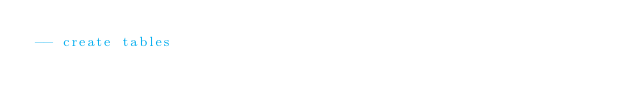<code> <loc_0><loc_0><loc_500><loc_500><_SQL_>-- create tables </code> 